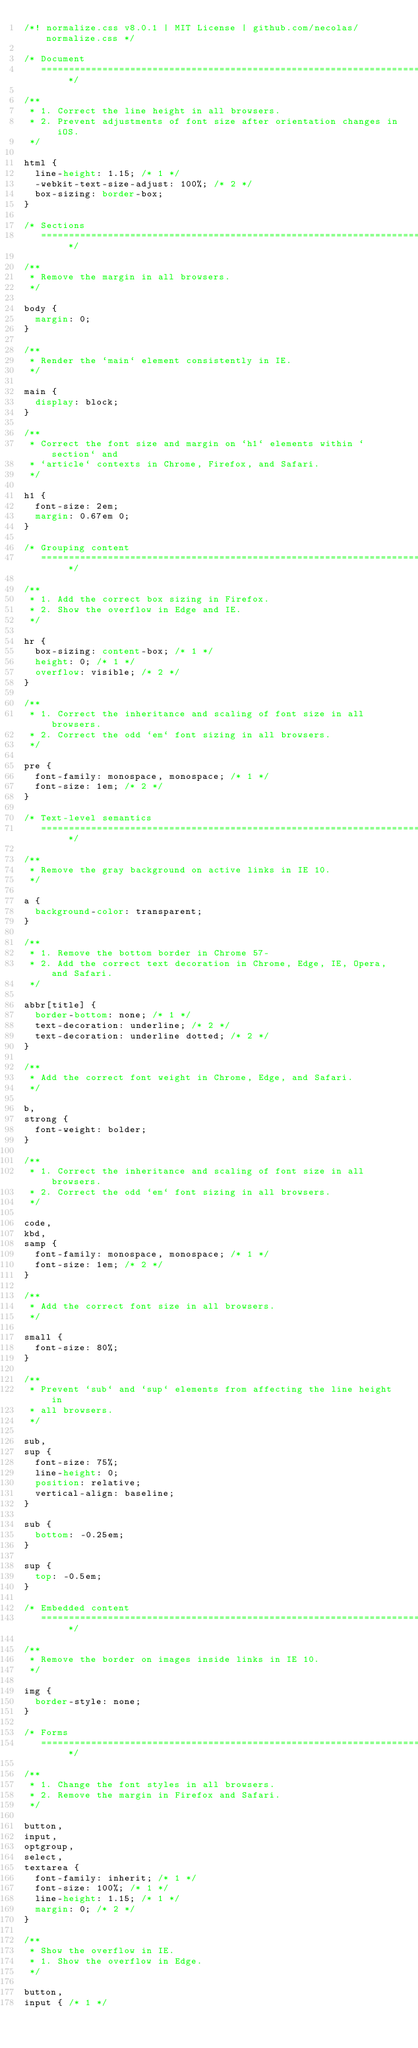Convert code to text. <code><loc_0><loc_0><loc_500><loc_500><_CSS_>/*! normalize.css v8.0.1 | MIT License | github.com/necolas/normalize.css */

/* Document
   ========================================================================== */

/**
 * 1. Correct the line height in all browsers.
 * 2. Prevent adjustments of font size after orientation changes in iOS.
 */

html {
  line-height: 1.15; /* 1 */
  -webkit-text-size-adjust: 100%; /* 2 */
  box-sizing: border-box;
}

/* Sections
   ========================================================================== */

/**
 * Remove the margin in all browsers.
 */

body {
  margin: 0;
}

/**
 * Render the `main` element consistently in IE.
 */

main {
  display: block;
}

/**
 * Correct the font size and margin on `h1` elements within `section` and
 * `article` contexts in Chrome, Firefox, and Safari.
 */

h1 {
  font-size: 2em;
  margin: 0.67em 0;
}

/* Grouping content
   ========================================================================== */

/**
 * 1. Add the correct box sizing in Firefox.
 * 2. Show the overflow in Edge and IE.
 */

hr {
  box-sizing: content-box; /* 1 */
  height: 0; /* 1 */
  overflow: visible; /* 2 */
}

/**
 * 1. Correct the inheritance and scaling of font size in all browsers.
 * 2. Correct the odd `em` font sizing in all browsers.
 */

pre {
  font-family: monospace, monospace; /* 1 */
  font-size: 1em; /* 2 */
}

/* Text-level semantics
   ========================================================================== */

/**
 * Remove the gray background on active links in IE 10.
 */

a {
  background-color: transparent;
}

/**
 * 1. Remove the bottom border in Chrome 57-
 * 2. Add the correct text decoration in Chrome, Edge, IE, Opera, and Safari.
 */

abbr[title] {
  border-bottom: none; /* 1 */
  text-decoration: underline; /* 2 */
  text-decoration: underline dotted; /* 2 */
}

/**
 * Add the correct font weight in Chrome, Edge, and Safari.
 */

b,
strong {
  font-weight: bolder;
}

/**
 * 1. Correct the inheritance and scaling of font size in all browsers.
 * 2. Correct the odd `em` font sizing in all browsers.
 */

code,
kbd,
samp {
  font-family: monospace, monospace; /* 1 */
  font-size: 1em; /* 2 */
}

/**
 * Add the correct font size in all browsers.
 */

small {
  font-size: 80%;
}

/**
 * Prevent `sub` and `sup` elements from affecting the line height in
 * all browsers.
 */

sub,
sup {
  font-size: 75%;
  line-height: 0;
  position: relative;
  vertical-align: baseline;
}

sub {
  bottom: -0.25em;
}

sup {
  top: -0.5em;
}

/* Embedded content
   ========================================================================== */

/**
 * Remove the border on images inside links in IE 10.
 */

img {
  border-style: none;
}

/* Forms
   ========================================================================== */

/**
 * 1. Change the font styles in all browsers.
 * 2. Remove the margin in Firefox and Safari.
 */

button,
input,
optgroup,
select,
textarea {
  font-family: inherit; /* 1 */
  font-size: 100%; /* 1 */
  line-height: 1.15; /* 1 */
  margin: 0; /* 2 */
}

/**
 * Show the overflow in IE.
 * 1. Show the overflow in Edge.
 */

button,
input { /* 1 */</code> 